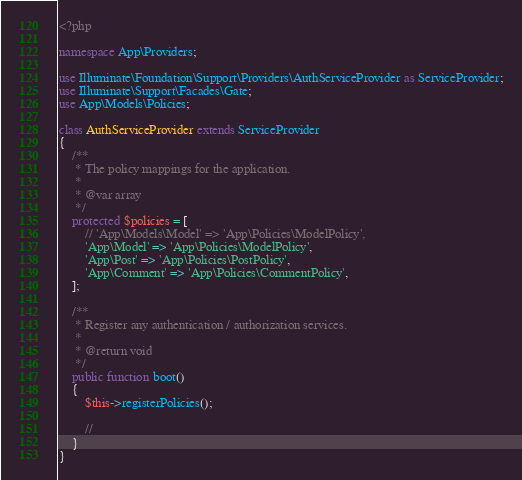<code> <loc_0><loc_0><loc_500><loc_500><_PHP_><?php

namespace App\Providers;

use Illuminate\Foundation\Support\Providers\AuthServiceProvider as ServiceProvider;
use Illuminate\Support\Facades\Gate;
use App\Models\Policies;

class AuthServiceProvider extends ServiceProvider
{
    /**
     * The policy mappings for the application.
     *
     * @var array
     */
    protected $policies = [
        // 'App\Models\Model' => 'App\Policies\ModelPolicy',
        'App\Model' => 'App\Policies\ModelPolicy',
        'App\Post' => 'App\Policies\PostPolicy',
        'App\Comment' => 'App\Policies\CommentPolicy',
    ];

    /**
     * Register any authentication / authorization services.
     *
     * @return void
     */
    public function boot()
    {
        $this->registerPolicies();

        //
    }
}
</code> 